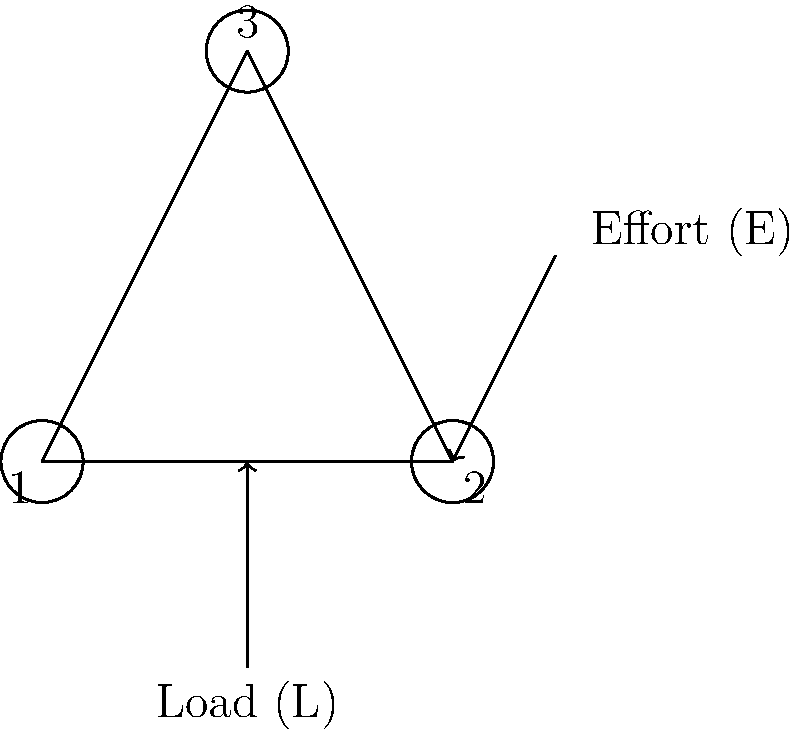In the pulley system shown above, there are three pulleys: two fixed (1 and 2) and one movable (3). The load (L) is attached to the movable pulley. If the load weighs 600 N, what is the minimum effort (E) required to lift it, assuming the system is ideal with no friction? Express your answer in Newtons. To solve this problem, we need to understand the concept of mechanical advantage in a pulley system. Let's break it down step-by-step:

1. First, we need to determine the mechanical advantage (MA) of this pulley system.
   - In an ideal pulley system, the MA is equal to the number of rope segments supporting the load.
   - In this case, there are two rope segments supporting the movable pulley (and thus the load).

2. The mechanical advantage (MA) is therefore 2.

3. The relationship between mechanical advantage, effort (E), and load (L) is:
   $$ MA = \frac{L}{E} $$

4. We can rearrange this equation to solve for the effort:
   $$ E = \frac{L}{MA} $$

5. Now, let's plug in our known values:
   - Load (L) = 600 N
   - Mechanical Advantage (MA) = 2

6. Calculating the effort:
   $$ E = \frac{600 \text{ N}}{2} = 300 \text{ N} $$

Therefore, the minimum effort required to lift the load is 300 N.
Answer: 300 N 